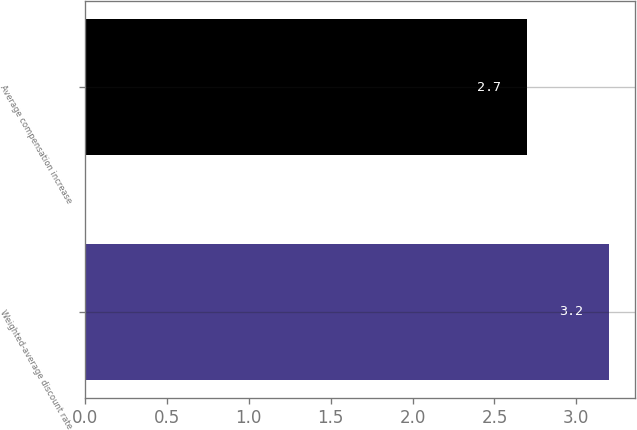<chart> <loc_0><loc_0><loc_500><loc_500><bar_chart><fcel>Weighted-average discount rate<fcel>Average compensation increase<nl><fcel>3.2<fcel>2.7<nl></chart> 